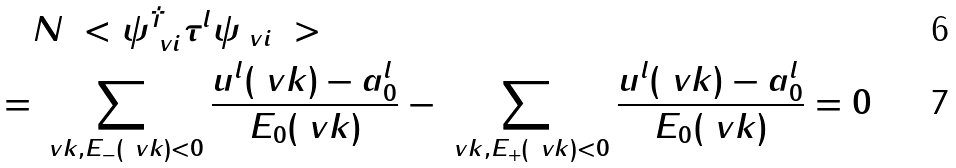Convert formula to latex. <formula><loc_0><loc_0><loc_500><loc_500>& N \ < \psi _ { \ v i } ^ { \dag } \tau ^ { l } \psi _ { \ v i } \ > \\ = & \sum _ { \ v k , E _ { - } ( \ v k ) < 0 } \frac { u ^ { l } ( \ v k ) - a _ { 0 } ^ { l } } { E _ { 0 } ( \ v k ) } - \sum _ { \ v k , E _ { + } ( \ v k ) < 0 } \frac { u ^ { l } ( \ v k ) - a _ { 0 } ^ { l } } { E _ { 0 } ( \ v k ) } = 0</formula> 